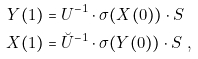Convert formula to latex. <formula><loc_0><loc_0><loc_500><loc_500>Y ( 1 ) & = U ^ { - 1 } \cdot \sigma ( X ( 0 ) ) \cdot S \\ X ( 1 ) & = \breve { U } ^ { - 1 } \cdot \sigma ( Y ( 0 ) ) \cdot S \ ,</formula> 